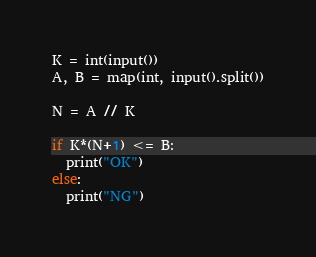Convert code to text. <code><loc_0><loc_0><loc_500><loc_500><_Python_>K = int(input())
A, B = map(int, input().split())

N = A // K

if K*(N+1) <= B:
  print("OK")
else:
  print("NG")</code> 